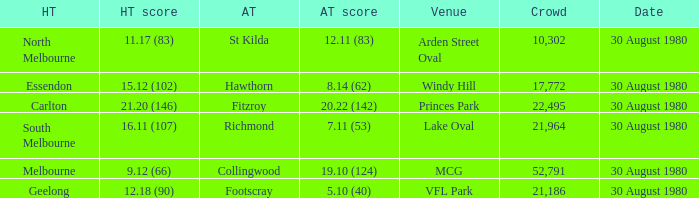What was the crowd when the away team is footscray? 21186.0. 